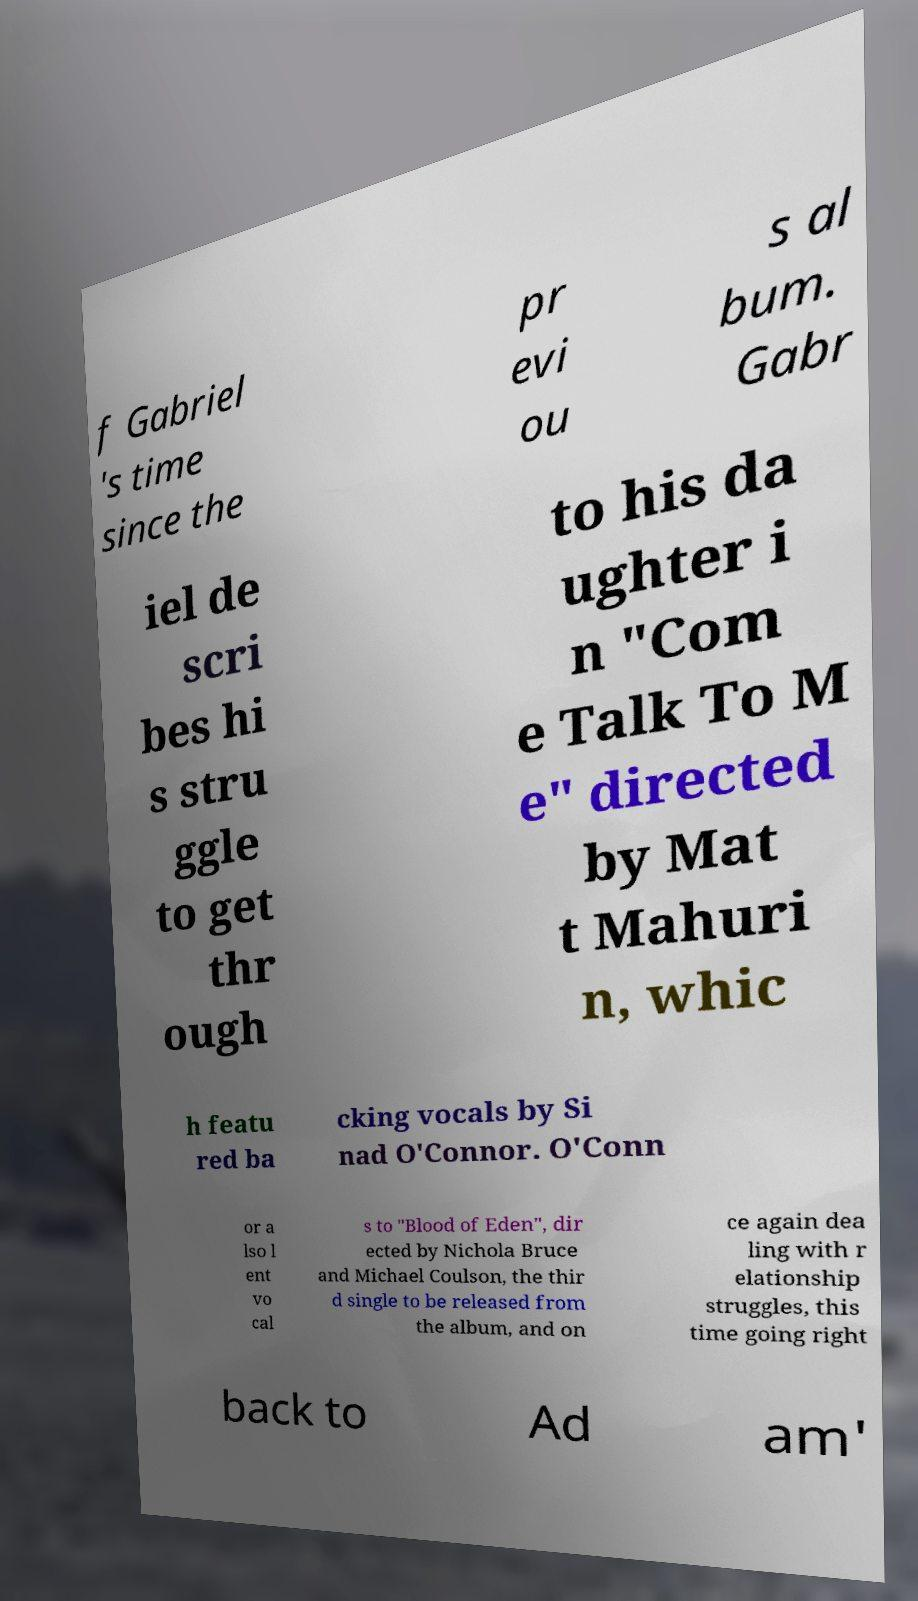For documentation purposes, I need the text within this image transcribed. Could you provide that? f Gabriel 's time since the pr evi ou s al bum. Gabr iel de scri bes hi s stru ggle to get thr ough to his da ughter i n "Com e Talk To M e" directed by Mat t Mahuri n, whic h featu red ba cking vocals by Si nad O'Connor. O'Conn or a lso l ent vo cal s to "Blood of Eden", dir ected by Nichola Bruce and Michael Coulson, the thir d single to be released from the album, and on ce again dea ling with r elationship struggles, this time going right back to Ad am' 